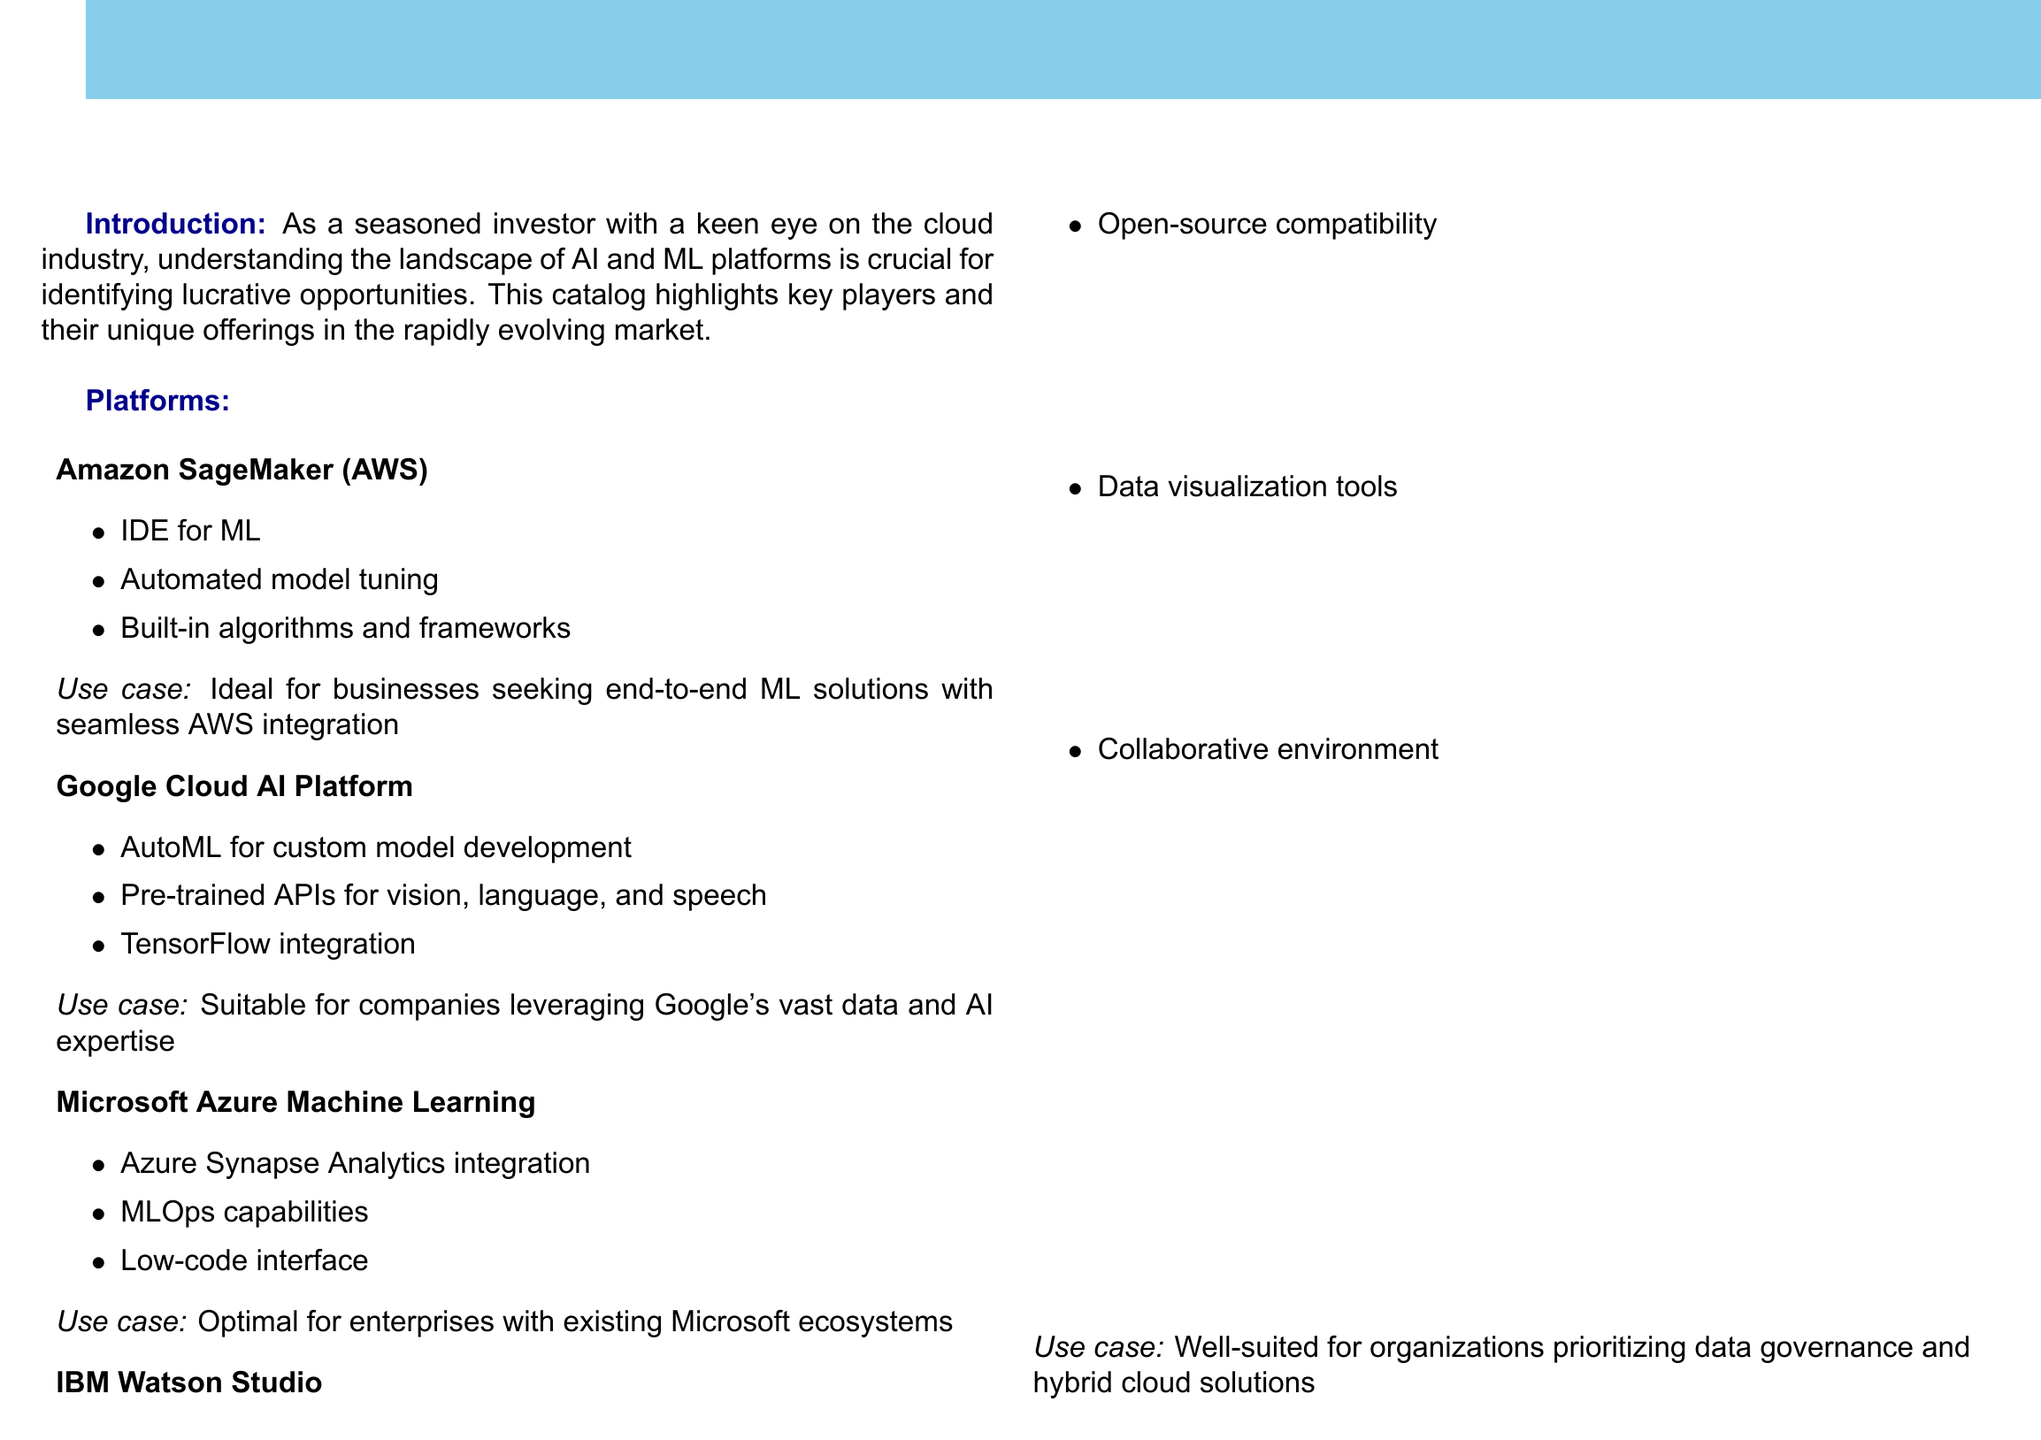What is the first platform listed? The first platform appears as Amazon SageMaker under the platforms section.
Answer: Amazon SageMaker What unique feature does Google Cloud AI Platform offer? The Google Cloud AI Platform includes AutoML for custom model development among its features.
Answer: AutoML Which platform is optimal for enterprises with existing Microsoft ecosystems? The document states that Microsoft Azure Machine Learning is optimal for such enterprises.
Answer: Microsoft Azure Machine Learning What color scheme is used for the background of the document? The document uses a cloud blue color for the background.
Answer: Cloud blue What are one of the investment considerations mentioned? The investment considerations include several aspects, one of them being market share and growth potential.
Answer: Market share and growth potential Which platform prioritizes data governance and hybrid cloud solutions? The document specifies that IBM Watson Studio is well-suited for organizations focusing on these areas.
Answer: IBM Watson Studio How many platforms are detailed in the document? The document discusses four platforms in total.
Answer: Four What type of integration does Microsoft Azure Machine Learning offer? Microsoft Azure Machine Learning offers Azure Synapse Analytics integration.
Answer: Azure Synapse Analytics integration What is the main purpose of the catalog? The main purpose of the catalog is to highlight key players and unique offerings in the AI and ML market for investors.
Answer: Highlight key players and unique offerings 